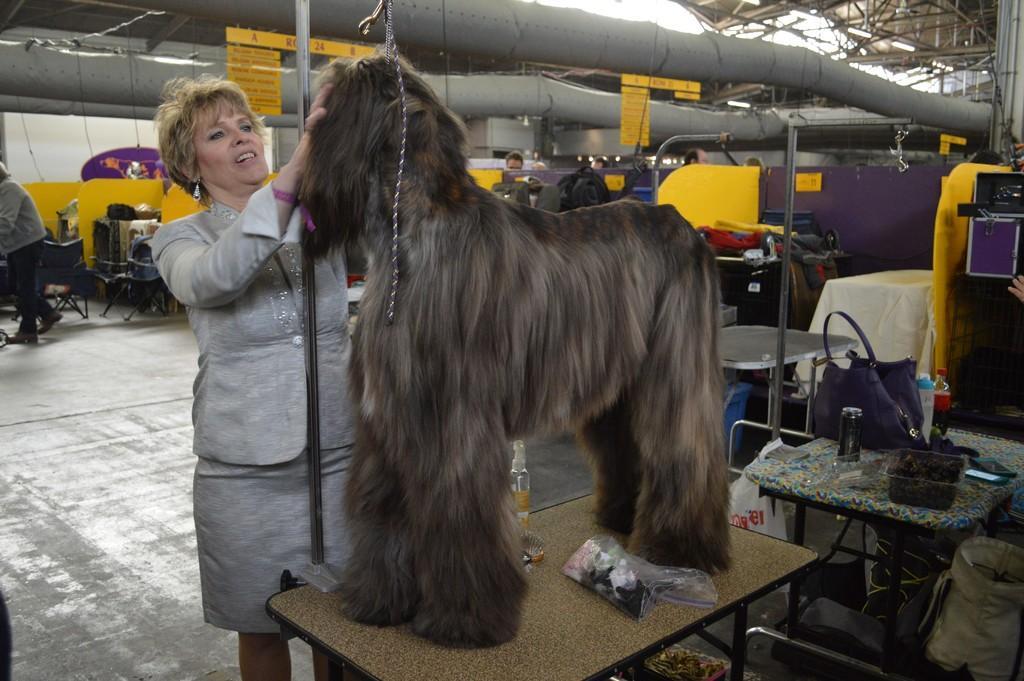Can you describe this image briefly? The woman is catching a dog which is on the table, In background there are yellow cabins. 